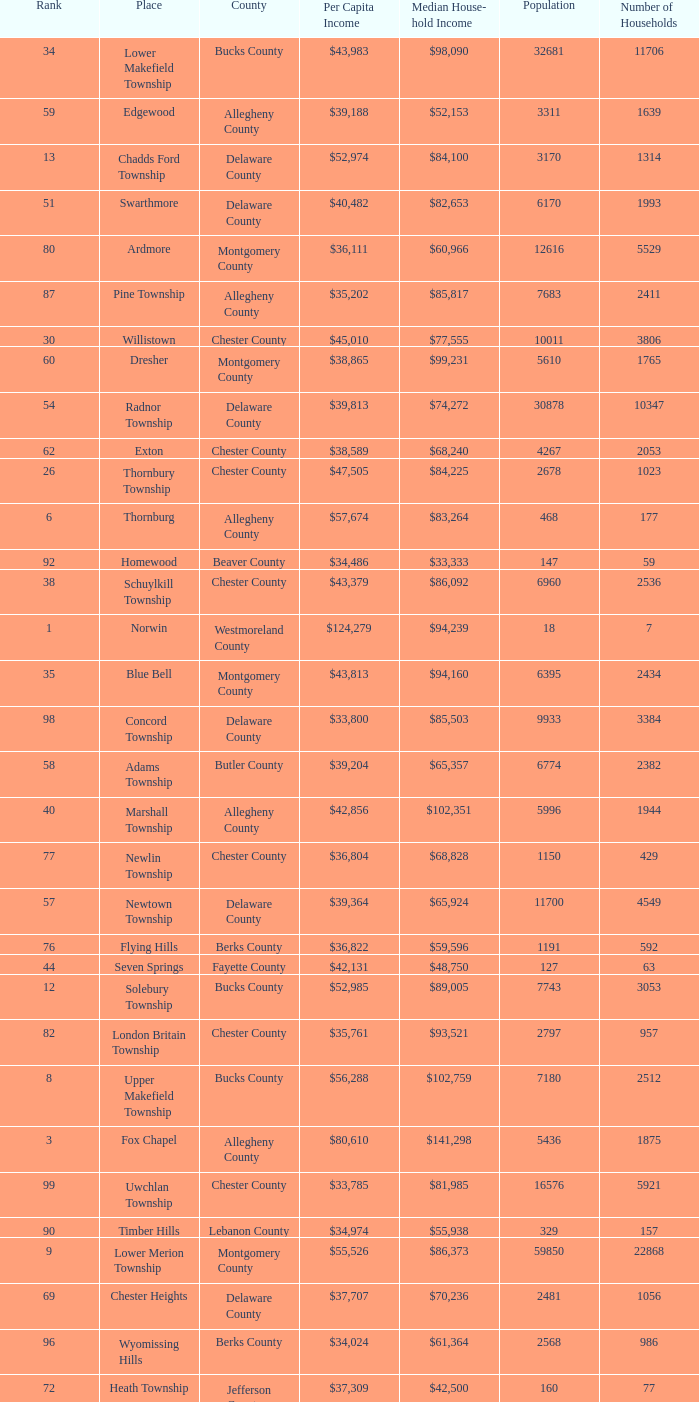Which county has a median household income of  $98,090? Bucks County. 